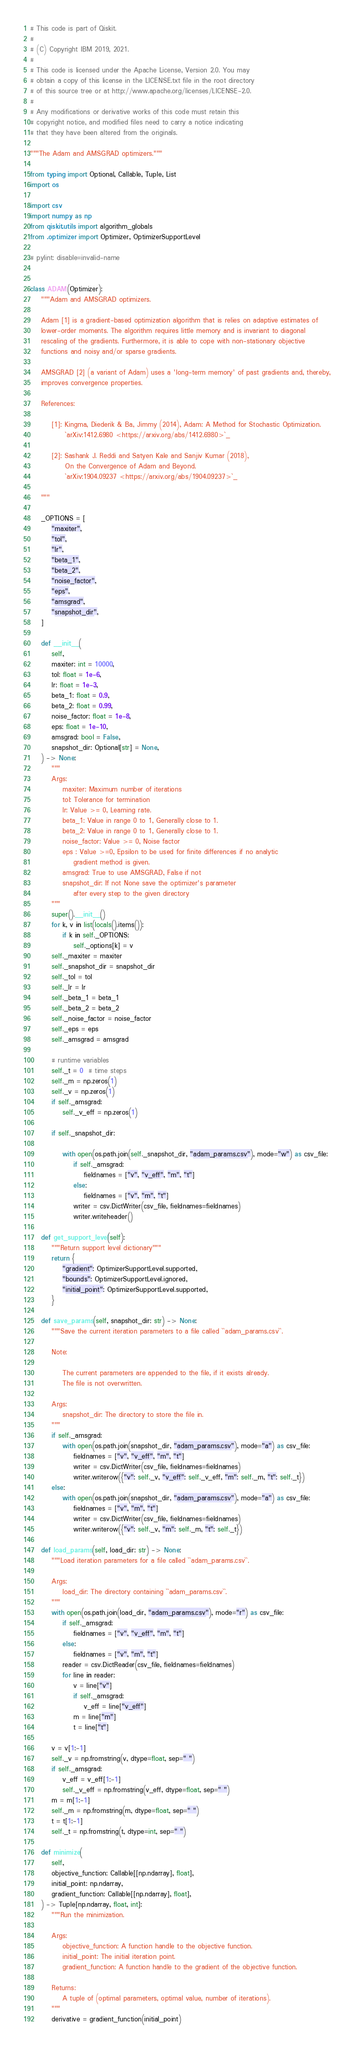<code> <loc_0><loc_0><loc_500><loc_500><_Python_># This code is part of Qiskit.
#
# (C) Copyright IBM 2019, 2021.
#
# This code is licensed under the Apache License, Version 2.0. You may
# obtain a copy of this license in the LICENSE.txt file in the root directory
# of this source tree or at http://www.apache.org/licenses/LICENSE-2.0.
#
# Any modifications or derivative works of this code must retain this
# copyright notice, and modified files need to carry a notice indicating
# that they have been altered from the originals.

"""The Adam and AMSGRAD optimizers."""

from typing import Optional, Callable, Tuple, List
import os

import csv
import numpy as np
from qiskit.utils import algorithm_globals
from .optimizer import Optimizer, OptimizerSupportLevel

# pylint: disable=invalid-name


class ADAM(Optimizer):
    """Adam and AMSGRAD optimizers.

    Adam [1] is a gradient-based optimization algorithm that is relies on adaptive estimates of
    lower-order moments. The algorithm requires little memory and is invariant to diagonal
    rescaling of the gradients. Furthermore, it is able to cope with non-stationary objective
    functions and noisy and/or sparse gradients.

    AMSGRAD [2] (a variant of Adam) uses a 'long-term memory' of past gradients and, thereby,
    improves convergence properties.

    References:

        [1]: Kingma, Diederik & Ba, Jimmy (2014), Adam: A Method for Stochastic Optimization.
             `arXiv:1412.6980 <https://arxiv.org/abs/1412.6980>`_

        [2]: Sashank J. Reddi and Satyen Kale and Sanjiv Kumar (2018),
             On the Convergence of Adam and Beyond.
             `arXiv:1904.09237 <https://arxiv.org/abs/1904.09237>`_

    """

    _OPTIONS = [
        "maxiter",
        "tol",
        "lr",
        "beta_1",
        "beta_2",
        "noise_factor",
        "eps",
        "amsgrad",
        "snapshot_dir",
    ]

    def __init__(
        self,
        maxiter: int = 10000,
        tol: float = 1e-6,
        lr: float = 1e-3,
        beta_1: float = 0.9,
        beta_2: float = 0.99,
        noise_factor: float = 1e-8,
        eps: float = 1e-10,
        amsgrad: bool = False,
        snapshot_dir: Optional[str] = None,
    ) -> None:
        """
        Args:
            maxiter: Maximum number of iterations
            tol: Tolerance for termination
            lr: Value >= 0, Learning rate.
            beta_1: Value in range 0 to 1, Generally close to 1.
            beta_2: Value in range 0 to 1, Generally close to 1.
            noise_factor: Value >= 0, Noise factor
            eps : Value >=0, Epsilon to be used for finite differences if no analytic
                gradient method is given.
            amsgrad: True to use AMSGRAD, False if not
            snapshot_dir: If not None save the optimizer's parameter
                after every step to the given directory
        """
        super().__init__()
        for k, v in list(locals().items()):
            if k in self._OPTIONS:
                self._options[k] = v
        self._maxiter = maxiter
        self._snapshot_dir = snapshot_dir
        self._tol = tol
        self._lr = lr
        self._beta_1 = beta_1
        self._beta_2 = beta_2
        self._noise_factor = noise_factor
        self._eps = eps
        self._amsgrad = amsgrad

        # runtime variables
        self._t = 0  # time steps
        self._m = np.zeros(1)
        self._v = np.zeros(1)
        if self._amsgrad:
            self._v_eff = np.zeros(1)

        if self._snapshot_dir:

            with open(os.path.join(self._snapshot_dir, "adam_params.csv"), mode="w") as csv_file:
                if self._amsgrad:
                    fieldnames = ["v", "v_eff", "m", "t"]
                else:
                    fieldnames = ["v", "m", "t"]
                writer = csv.DictWriter(csv_file, fieldnames=fieldnames)
                writer.writeheader()

    def get_support_level(self):
        """Return support level dictionary"""
        return {
            "gradient": OptimizerSupportLevel.supported,
            "bounds": OptimizerSupportLevel.ignored,
            "initial_point": OptimizerSupportLevel.supported,
        }

    def save_params(self, snapshot_dir: str) -> None:
        """Save the current iteration parameters to a file called ``adam_params.csv``.

        Note:

            The current parameters are appended to the file, if it exists already.
            The file is not overwritten.

        Args:
            snapshot_dir: The directory to store the file in.
        """
        if self._amsgrad:
            with open(os.path.join(snapshot_dir, "adam_params.csv"), mode="a") as csv_file:
                fieldnames = ["v", "v_eff", "m", "t"]
                writer = csv.DictWriter(csv_file, fieldnames=fieldnames)
                writer.writerow({"v": self._v, "v_eff": self._v_eff, "m": self._m, "t": self._t})
        else:
            with open(os.path.join(snapshot_dir, "adam_params.csv"), mode="a") as csv_file:
                fieldnames = ["v", "m", "t"]
                writer = csv.DictWriter(csv_file, fieldnames=fieldnames)
                writer.writerow({"v": self._v, "m": self._m, "t": self._t})

    def load_params(self, load_dir: str) -> None:
        """Load iteration parameters for a file called ``adam_params.csv``.

        Args:
            load_dir: The directory containing ``adam_params.csv``.
        """
        with open(os.path.join(load_dir, "adam_params.csv"), mode="r") as csv_file:
            if self._amsgrad:
                fieldnames = ["v", "v_eff", "m", "t"]
            else:
                fieldnames = ["v", "m", "t"]
            reader = csv.DictReader(csv_file, fieldnames=fieldnames)
            for line in reader:
                v = line["v"]
                if self._amsgrad:
                    v_eff = line["v_eff"]
                m = line["m"]
                t = line["t"]

        v = v[1:-1]
        self._v = np.fromstring(v, dtype=float, sep=" ")
        if self._amsgrad:
            v_eff = v_eff[1:-1]
            self._v_eff = np.fromstring(v_eff, dtype=float, sep=" ")
        m = m[1:-1]
        self._m = np.fromstring(m, dtype=float, sep=" ")
        t = t[1:-1]
        self._t = np.fromstring(t, dtype=int, sep=" ")

    def minimize(
        self,
        objective_function: Callable[[np.ndarray], float],
        initial_point: np.ndarray,
        gradient_function: Callable[[np.ndarray], float],
    ) -> Tuple[np.ndarray, float, int]:
        """Run the minimization.

        Args:
            objective_function: A function handle to the objective function.
            initial_point: The initial iteration point.
            gradient_function: A function handle to the gradient of the objective function.

        Returns:
            A tuple of (optimal parameters, optimal value, number of iterations).
        """
        derivative = gradient_function(initial_point)</code> 